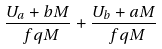<formula> <loc_0><loc_0><loc_500><loc_500>\frac { U _ { a } + b M } { \ f { q } M } + \frac { U _ { b } + a M } { \ f { q } M }</formula> 